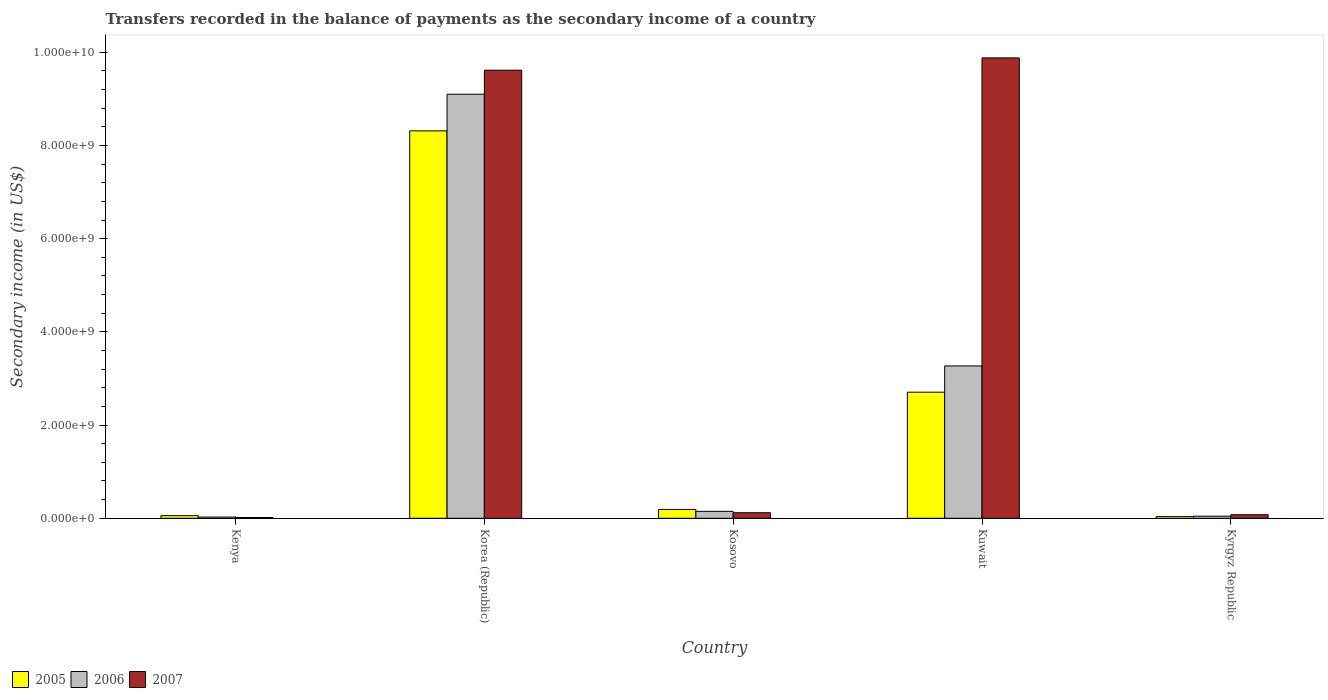How many different coloured bars are there?
Ensure brevity in your answer.  3. Are the number of bars on each tick of the X-axis equal?
Ensure brevity in your answer.  Yes. What is the label of the 3rd group of bars from the left?
Your answer should be compact. Kosovo. What is the secondary income of in 2005 in Kosovo?
Provide a succinct answer. 1.90e+08. Across all countries, what is the maximum secondary income of in 2005?
Provide a succinct answer. 8.31e+09. Across all countries, what is the minimum secondary income of in 2007?
Ensure brevity in your answer.  1.64e+07. In which country was the secondary income of in 2006 maximum?
Provide a short and direct response. Korea (Republic). In which country was the secondary income of in 2005 minimum?
Keep it short and to the point. Kyrgyz Republic. What is the total secondary income of in 2005 in the graph?
Offer a terse response. 1.13e+1. What is the difference between the secondary income of in 2005 in Korea (Republic) and that in Kuwait?
Ensure brevity in your answer.  5.61e+09. What is the difference between the secondary income of in 2006 in Kuwait and the secondary income of in 2007 in Korea (Republic)?
Make the answer very short. -6.35e+09. What is the average secondary income of in 2006 per country?
Offer a very short reply. 2.52e+09. What is the difference between the secondary income of of/in 2005 and secondary income of of/in 2007 in Kosovo?
Keep it short and to the point. 7.07e+07. In how many countries, is the secondary income of in 2006 greater than 1600000000 US$?
Offer a very short reply. 2. What is the ratio of the secondary income of in 2006 in Kenya to that in Korea (Republic)?
Give a very brief answer. 0. Is the difference between the secondary income of in 2005 in Kenya and Kuwait greater than the difference between the secondary income of in 2007 in Kenya and Kuwait?
Give a very brief answer. Yes. What is the difference between the highest and the second highest secondary income of in 2007?
Your response must be concise. -2.64e+08. What is the difference between the highest and the lowest secondary income of in 2005?
Give a very brief answer. 8.28e+09. Is it the case that in every country, the sum of the secondary income of in 2006 and secondary income of in 2005 is greater than the secondary income of in 2007?
Offer a terse response. No. How many bars are there?
Give a very brief answer. 15. Are all the bars in the graph horizontal?
Offer a terse response. No. How many countries are there in the graph?
Keep it short and to the point. 5. Are the values on the major ticks of Y-axis written in scientific E-notation?
Your answer should be very brief. Yes. Does the graph contain grids?
Your answer should be compact. No. Where does the legend appear in the graph?
Provide a short and direct response. Bottom left. How are the legend labels stacked?
Provide a succinct answer. Horizontal. What is the title of the graph?
Your answer should be very brief. Transfers recorded in the balance of payments as the secondary income of a country. Does "1978" appear as one of the legend labels in the graph?
Provide a succinct answer. No. What is the label or title of the X-axis?
Keep it short and to the point. Country. What is the label or title of the Y-axis?
Your response must be concise. Secondary income (in US$). What is the Secondary income (in US$) in 2005 in Kenya?
Make the answer very short. 5.64e+07. What is the Secondary income (in US$) in 2006 in Kenya?
Offer a terse response. 2.54e+07. What is the Secondary income (in US$) of 2007 in Kenya?
Your response must be concise. 1.64e+07. What is the Secondary income (in US$) of 2005 in Korea (Republic)?
Make the answer very short. 8.31e+09. What is the Secondary income (in US$) of 2006 in Korea (Republic)?
Make the answer very short. 9.10e+09. What is the Secondary income (in US$) of 2007 in Korea (Republic)?
Give a very brief answer. 9.62e+09. What is the Secondary income (in US$) in 2005 in Kosovo?
Offer a very short reply. 1.90e+08. What is the Secondary income (in US$) of 2006 in Kosovo?
Provide a succinct answer. 1.48e+08. What is the Secondary income (in US$) in 2007 in Kosovo?
Provide a short and direct response. 1.19e+08. What is the Secondary income (in US$) in 2005 in Kuwait?
Give a very brief answer. 2.71e+09. What is the Secondary income (in US$) of 2006 in Kuwait?
Keep it short and to the point. 3.27e+09. What is the Secondary income (in US$) of 2007 in Kuwait?
Your answer should be very brief. 9.88e+09. What is the Secondary income (in US$) in 2005 in Kyrgyz Republic?
Your answer should be compact. 3.63e+07. What is the Secondary income (in US$) of 2006 in Kyrgyz Republic?
Ensure brevity in your answer.  4.53e+07. What is the Secondary income (in US$) in 2007 in Kyrgyz Republic?
Keep it short and to the point. 7.56e+07. Across all countries, what is the maximum Secondary income (in US$) of 2005?
Give a very brief answer. 8.31e+09. Across all countries, what is the maximum Secondary income (in US$) of 2006?
Provide a succinct answer. 9.10e+09. Across all countries, what is the maximum Secondary income (in US$) of 2007?
Your response must be concise. 9.88e+09. Across all countries, what is the minimum Secondary income (in US$) in 2005?
Provide a short and direct response. 3.63e+07. Across all countries, what is the minimum Secondary income (in US$) in 2006?
Offer a very short reply. 2.54e+07. Across all countries, what is the minimum Secondary income (in US$) of 2007?
Give a very brief answer. 1.64e+07. What is the total Secondary income (in US$) of 2005 in the graph?
Give a very brief answer. 1.13e+1. What is the total Secondary income (in US$) of 2006 in the graph?
Offer a terse response. 1.26e+1. What is the total Secondary income (in US$) of 2007 in the graph?
Make the answer very short. 1.97e+1. What is the difference between the Secondary income (in US$) of 2005 in Kenya and that in Korea (Republic)?
Offer a very short reply. -8.26e+09. What is the difference between the Secondary income (in US$) in 2006 in Kenya and that in Korea (Republic)?
Keep it short and to the point. -9.08e+09. What is the difference between the Secondary income (in US$) in 2007 in Kenya and that in Korea (Republic)?
Provide a succinct answer. -9.60e+09. What is the difference between the Secondary income (in US$) in 2005 in Kenya and that in Kosovo?
Provide a short and direct response. -1.33e+08. What is the difference between the Secondary income (in US$) in 2006 in Kenya and that in Kosovo?
Ensure brevity in your answer.  -1.23e+08. What is the difference between the Secondary income (in US$) in 2007 in Kenya and that in Kosovo?
Make the answer very short. -1.02e+08. What is the difference between the Secondary income (in US$) in 2005 in Kenya and that in Kuwait?
Provide a short and direct response. -2.65e+09. What is the difference between the Secondary income (in US$) in 2006 in Kenya and that in Kuwait?
Your response must be concise. -3.24e+09. What is the difference between the Secondary income (in US$) of 2007 in Kenya and that in Kuwait?
Your answer should be compact. -9.86e+09. What is the difference between the Secondary income (in US$) in 2005 in Kenya and that in Kyrgyz Republic?
Give a very brief answer. 2.01e+07. What is the difference between the Secondary income (in US$) in 2006 in Kenya and that in Kyrgyz Republic?
Your answer should be very brief. -1.99e+07. What is the difference between the Secondary income (in US$) in 2007 in Kenya and that in Kyrgyz Republic?
Provide a succinct answer. -5.92e+07. What is the difference between the Secondary income (in US$) of 2005 in Korea (Republic) and that in Kosovo?
Keep it short and to the point. 8.12e+09. What is the difference between the Secondary income (in US$) in 2006 in Korea (Republic) and that in Kosovo?
Offer a terse response. 8.95e+09. What is the difference between the Secondary income (in US$) in 2007 in Korea (Republic) and that in Kosovo?
Provide a short and direct response. 9.50e+09. What is the difference between the Secondary income (in US$) in 2005 in Korea (Republic) and that in Kuwait?
Your response must be concise. 5.61e+09. What is the difference between the Secondary income (in US$) in 2006 in Korea (Republic) and that in Kuwait?
Give a very brief answer. 5.83e+09. What is the difference between the Secondary income (in US$) of 2007 in Korea (Republic) and that in Kuwait?
Your answer should be compact. -2.64e+08. What is the difference between the Secondary income (in US$) in 2005 in Korea (Republic) and that in Kyrgyz Republic?
Offer a very short reply. 8.28e+09. What is the difference between the Secondary income (in US$) in 2006 in Korea (Republic) and that in Kyrgyz Republic?
Keep it short and to the point. 9.06e+09. What is the difference between the Secondary income (in US$) in 2007 in Korea (Republic) and that in Kyrgyz Republic?
Your response must be concise. 9.54e+09. What is the difference between the Secondary income (in US$) in 2005 in Kosovo and that in Kuwait?
Provide a succinct answer. -2.52e+09. What is the difference between the Secondary income (in US$) of 2006 in Kosovo and that in Kuwait?
Offer a terse response. -3.12e+09. What is the difference between the Secondary income (in US$) in 2007 in Kosovo and that in Kuwait?
Offer a terse response. -9.76e+09. What is the difference between the Secondary income (in US$) in 2005 in Kosovo and that in Kyrgyz Republic?
Your response must be concise. 1.53e+08. What is the difference between the Secondary income (in US$) of 2006 in Kosovo and that in Kyrgyz Republic?
Ensure brevity in your answer.  1.03e+08. What is the difference between the Secondary income (in US$) in 2007 in Kosovo and that in Kyrgyz Republic?
Give a very brief answer. 4.33e+07. What is the difference between the Secondary income (in US$) in 2005 in Kuwait and that in Kyrgyz Republic?
Offer a terse response. 2.67e+09. What is the difference between the Secondary income (in US$) in 2006 in Kuwait and that in Kyrgyz Republic?
Keep it short and to the point. 3.22e+09. What is the difference between the Secondary income (in US$) of 2007 in Kuwait and that in Kyrgyz Republic?
Provide a succinct answer. 9.80e+09. What is the difference between the Secondary income (in US$) in 2005 in Kenya and the Secondary income (in US$) in 2006 in Korea (Republic)?
Your response must be concise. -9.04e+09. What is the difference between the Secondary income (in US$) of 2005 in Kenya and the Secondary income (in US$) of 2007 in Korea (Republic)?
Offer a very short reply. -9.56e+09. What is the difference between the Secondary income (in US$) of 2006 in Kenya and the Secondary income (in US$) of 2007 in Korea (Republic)?
Make the answer very short. -9.59e+09. What is the difference between the Secondary income (in US$) of 2005 in Kenya and the Secondary income (in US$) of 2006 in Kosovo?
Offer a very short reply. -9.21e+07. What is the difference between the Secondary income (in US$) of 2005 in Kenya and the Secondary income (in US$) of 2007 in Kosovo?
Ensure brevity in your answer.  -6.24e+07. What is the difference between the Secondary income (in US$) of 2006 in Kenya and the Secondary income (in US$) of 2007 in Kosovo?
Provide a succinct answer. -9.34e+07. What is the difference between the Secondary income (in US$) of 2005 in Kenya and the Secondary income (in US$) of 2006 in Kuwait?
Ensure brevity in your answer.  -3.21e+09. What is the difference between the Secondary income (in US$) in 2005 in Kenya and the Secondary income (in US$) in 2007 in Kuwait?
Make the answer very short. -9.82e+09. What is the difference between the Secondary income (in US$) of 2006 in Kenya and the Secondary income (in US$) of 2007 in Kuwait?
Offer a terse response. -9.85e+09. What is the difference between the Secondary income (in US$) of 2005 in Kenya and the Secondary income (in US$) of 2006 in Kyrgyz Republic?
Provide a succinct answer. 1.11e+07. What is the difference between the Secondary income (in US$) of 2005 in Kenya and the Secondary income (in US$) of 2007 in Kyrgyz Republic?
Your answer should be very brief. -1.92e+07. What is the difference between the Secondary income (in US$) of 2006 in Kenya and the Secondary income (in US$) of 2007 in Kyrgyz Republic?
Offer a very short reply. -5.02e+07. What is the difference between the Secondary income (in US$) of 2005 in Korea (Republic) and the Secondary income (in US$) of 2006 in Kosovo?
Your answer should be compact. 8.17e+09. What is the difference between the Secondary income (in US$) in 2005 in Korea (Republic) and the Secondary income (in US$) in 2007 in Kosovo?
Your answer should be very brief. 8.20e+09. What is the difference between the Secondary income (in US$) of 2006 in Korea (Republic) and the Secondary income (in US$) of 2007 in Kosovo?
Your response must be concise. 8.98e+09. What is the difference between the Secondary income (in US$) of 2005 in Korea (Republic) and the Secondary income (in US$) of 2006 in Kuwait?
Make the answer very short. 5.04e+09. What is the difference between the Secondary income (in US$) in 2005 in Korea (Republic) and the Secondary income (in US$) in 2007 in Kuwait?
Offer a terse response. -1.57e+09. What is the difference between the Secondary income (in US$) in 2006 in Korea (Republic) and the Secondary income (in US$) in 2007 in Kuwait?
Your answer should be very brief. -7.79e+08. What is the difference between the Secondary income (in US$) of 2005 in Korea (Republic) and the Secondary income (in US$) of 2006 in Kyrgyz Republic?
Your response must be concise. 8.27e+09. What is the difference between the Secondary income (in US$) of 2005 in Korea (Republic) and the Secondary income (in US$) of 2007 in Kyrgyz Republic?
Your answer should be very brief. 8.24e+09. What is the difference between the Secondary income (in US$) of 2006 in Korea (Republic) and the Secondary income (in US$) of 2007 in Kyrgyz Republic?
Keep it short and to the point. 9.02e+09. What is the difference between the Secondary income (in US$) in 2005 in Kosovo and the Secondary income (in US$) in 2006 in Kuwait?
Your answer should be compact. -3.08e+09. What is the difference between the Secondary income (in US$) in 2005 in Kosovo and the Secondary income (in US$) in 2007 in Kuwait?
Keep it short and to the point. -9.69e+09. What is the difference between the Secondary income (in US$) of 2006 in Kosovo and the Secondary income (in US$) of 2007 in Kuwait?
Provide a succinct answer. -9.73e+09. What is the difference between the Secondary income (in US$) of 2005 in Kosovo and the Secondary income (in US$) of 2006 in Kyrgyz Republic?
Offer a very short reply. 1.44e+08. What is the difference between the Secondary income (in US$) of 2005 in Kosovo and the Secondary income (in US$) of 2007 in Kyrgyz Republic?
Provide a succinct answer. 1.14e+08. What is the difference between the Secondary income (in US$) of 2006 in Kosovo and the Secondary income (in US$) of 2007 in Kyrgyz Republic?
Keep it short and to the point. 7.29e+07. What is the difference between the Secondary income (in US$) in 2005 in Kuwait and the Secondary income (in US$) in 2006 in Kyrgyz Republic?
Your answer should be very brief. 2.66e+09. What is the difference between the Secondary income (in US$) of 2005 in Kuwait and the Secondary income (in US$) of 2007 in Kyrgyz Republic?
Provide a short and direct response. 2.63e+09. What is the difference between the Secondary income (in US$) of 2006 in Kuwait and the Secondary income (in US$) of 2007 in Kyrgyz Republic?
Offer a terse response. 3.19e+09. What is the average Secondary income (in US$) of 2005 per country?
Offer a very short reply. 2.26e+09. What is the average Secondary income (in US$) of 2006 per country?
Give a very brief answer. 2.52e+09. What is the average Secondary income (in US$) in 2007 per country?
Your response must be concise. 3.94e+09. What is the difference between the Secondary income (in US$) of 2005 and Secondary income (in US$) of 2006 in Kenya?
Provide a succinct answer. 3.10e+07. What is the difference between the Secondary income (in US$) in 2005 and Secondary income (in US$) in 2007 in Kenya?
Your response must be concise. 4.00e+07. What is the difference between the Secondary income (in US$) in 2006 and Secondary income (in US$) in 2007 in Kenya?
Provide a short and direct response. 9.03e+06. What is the difference between the Secondary income (in US$) in 2005 and Secondary income (in US$) in 2006 in Korea (Republic)?
Provide a succinct answer. -7.86e+08. What is the difference between the Secondary income (in US$) in 2005 and Secondary income (in US$) in 2007 in Korea (Republic)?
Provide a succinct answer. -1.30e+09. What is the difference between the Secondary income (in US$) in 2006 and Secondary income (in US$) in 2007 in Korea (Republic)?
Ensure brevity in your answer.  -5.15e+08. What is the difference between the Secondary income (in US$) of 2005 and Secondary income (in US$) of 2006 in Kosovo?
Keep it short and to the point. 4.11e+07. What is the difference between the Secondary income (in US$) in 2005 and Secondary income (in US$) in 2007 in Kosovo?
Provide a short and direct response. 7.07e+07. What is the difference between the Secondary income (in US$) in 2006 and Secondary income (in US$) in 2007 in Kosovo?
Your response must be concise. 2.97e+07. What is the difference between the Secondary income (in US$) of 2005 and Secondary income (in US$) of 2006 in Kuwait?
Keep it short and to the point. -5.64e+08. What is the difference between the Secondary income (in US$) of 2005 and Secondary income (in US$) of 2007 in Kuwait?
Make the answer very short. -7.17e+09. What is the difference between the Secondary income (in US$) of 2006 and Secondary income (in US$) of 2007 in Kuwait?
Ensure brevity in your answer.  -6.61e+09. What is the difference between the Secondary income (in US$) of 2005 and Secondary income (in US$) of 2006 in Kyrgyz Republic?
Keep it short and to the point. -8.99e+06. What is the difference between the Secondary income (in US$) of 2005 and Secondary income (in US$) of 2007 in Kyrgyz Republic?
Your answer should be compact. -3.93e+07. What is the difference between the Secondary income (in US$) of 2006 and Secondary income (in US$) of 2007 in Kyrgyz Republic?
Your answer should be compact. -3.03e+07. What is the ratio of the Secondary income (in US$) of 2005 in Kenya to that in Korea (Republic)?
Provide a succinct answer. 0.01. What is the ratio of the Secondary income (in US$) of 2006 in Kenya to that in Korea (Republic)?
Your response must be concise. 0. What is the ratio of the Secondary income (in US$) in 2007 in Kenya to that in Korea (Republic)?
Your answer should be compact. 0. What is the ratio of the Secondary income (in US$) in 2005 in Kenya to that in Kosovo?
Your answer should be compact. 0.3. What is the ratio of the Secondary income (in US$) in 2006 in Kenya to that in Kosovo?
Make the answer very short. 0.17. What is the ratio of the Secondary income (in US$) of 2007 in Kenya to that in Kosovo?
Keep it short and to the point. 0.14. What is the ratio of the Secondary income (in US$) in 2005 in Kenya to that in Kuwait?
Provide a succinct answer. 0.02. What is the ratio of the Secondary income (in US$) of 2006 in Kenya to that in Kuwait?
Keep it short and to the point. 0.01. What is the ratio of the Secondary income (in US$) of 2007 in Kenya to that in Kuwait?
Ensure brevity in your answer.  0. What is the ratio of the Secondary income (in US$) of 2005 in Kenya to that in Kyrgyz Republic?
Offer a terse response. 1.55. What is the ratio of the Secondary income (in US$) of 2006 in Kenya to that in Kyrgyz Republic?
Your answer should be compact. 0.56. What is the ratio of the Secondary income (in US$) of 2007 in Kenya to that in Kyrgyz Republic?
Your answer should be very brief. 0.22. What is the ratio of the Secondary income (in US$) of 2005 in Korea (Republic) to that in Kosovo?
Offer a very short reply. 43.86. What is the ratio of the Secondary income (in US$) in 2006 in Korea (Republic) to that in Kosovo?
Give a very brief answer. 61.28. What is the ratio of the Secondary income (in US$) in 2007 in Korea (Republic) to that in Kosovo?
Offer a terse response. 80.91. What is the ratio of the Secondary income (in US$) of 2005 in Korea (Republic) to that in Kuwait?
Your answer should be compact. 3.07. What is the ratio of the Secondary income (in US$) in 2006 in Korea (Republic) to that in Kuwait?
Offer a very short reply. 2.78. What is the ratio of the Secondary income (in US$) of 2007 in Korea (Republic) to that in Kuwait?
Your answer should be compact. 0.97. What is the ratio of the Secondary income (in US$) in 2005 in Korea (Republic) to that in Kyrgyz Republic?
Offer a very short reply. 229.19. What is the ratio of the Secondary income (in US$) in 2006 in Korea (Republic) to that in Kyrgyz Republic?
Provide a succinct answer. 201.05. What is the ratio of the Secondary income (in US$) of 2007 in Korea (Republic) to that in Kyrgyz Republic?
Your response must be concise. 127.26. What is the ratio of the Secondary income (in US$) in 2005 in Kosovo to that in Kuwait?
Make the answer very short. 0.07. What is the ratio of the Secondary income (in US$) of 2006 in Kosovo to that in Kuwait?
Your response must be concise. 0.05. What is the ratio of the Secondary income (in US$) of 2007 in Kosovo to that in Kuwait?
Give a very brief answer. 0.01. What is the ratio of the Secondary income (in US$) of 2005 in Kosovo to that in Kyrgyz Republic?
Your response must be concise. 5.23. What is the ratio of the Secondary income (in US$) of 2006 in Kosovo to that in Kyrgyz Republic?
Your answer should be very brief. 3.28. What is the ratio of the Secondary income (in US$) in 2007 in Kosovo to that in Kyrgyz Republic?
Ensure brevity in your answer.  1.57. What is the ratio of the Secondary income (in US$) of 2005 in Kuwait to that in Kyrgyz Republic?
Keep it short and to the point. 74.58. What is the ratio of the Secondary income (in US$) in 2006 in Kuwait to that in Kyrgyz Republic?
Offer a terse response. 72.23. What is the ratio of the Secondary income (in US$) of 2007 in Kuwait to that in Kyrgyz Republic?
Provide a short and direct response. 130.76. What is the difference between the highest and the second highest Secondary income (in US$) of 2005?
Keep it short and to the point. 5.61e+09. What is the difference between the highest and the second highest Secondary income (in US$) in 2006?
Make the answer very short. 5.83e+09. What is the difference between the highest and the second highest Secondary income (in US$) of 2007?
Give a very brief answer. 2.64e+08. What is the difference between the highest and the lowest Secondary income (in US$) of 2005?
Provide a short and direct response. 8.28e+09. What is the difference between the highest and the lowest Secondary income (in US$) in 2006?
Offer a terse response. 9.08e+09. What is the difference between the highest and the lowest Secondary income (in US$) in 2007?
Make the answer very short. 9.86e+09. 